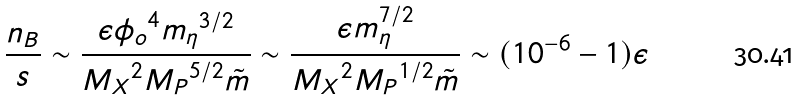<formula> <loc_0><loc_0><loc_500><loc_500>\frac { n _ { B } } { s } \sim \frac { \epsilon { \phi _ { o } } ^ { 4 } { m _ { \eta } } ^ { 3 / 2 } } { { M _ { X } } ^ { 2 } { M _ { P } } ^ { 5 / 2 } \tilde { m } } \sim \frac { \epsilon m _ { \eta } ^ { 7 / 2 } } { { M _ { X } } ^ { 2 } { M _ { P } } ^ { 1 / 2 } \tilde { m } } \sim ( 1 0 ^ { - 6 } - 1 ) \epsilon</formula> 